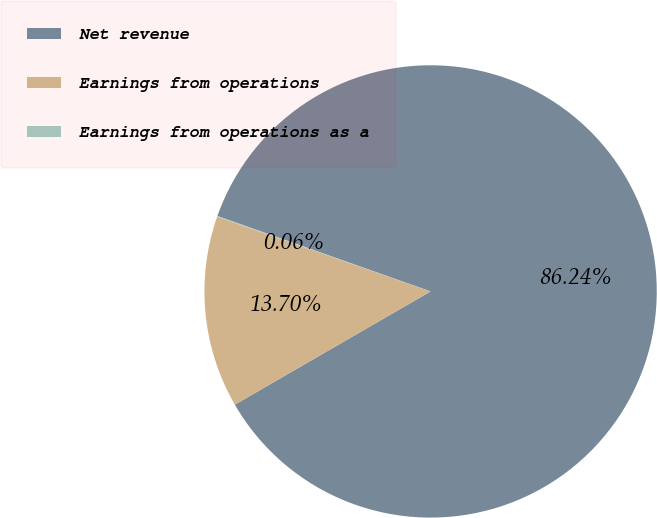Convert chart to OTSL. <chart><loc_0><loc_0><loc_500><loc_500><pie_chart><fcel>Net revenue<fcel>Earnings from operations<fcel>Earnings from operations as a<nl><fcel>86.25%<fcel>13.7%<fcel>0.06%<nl></chart> 